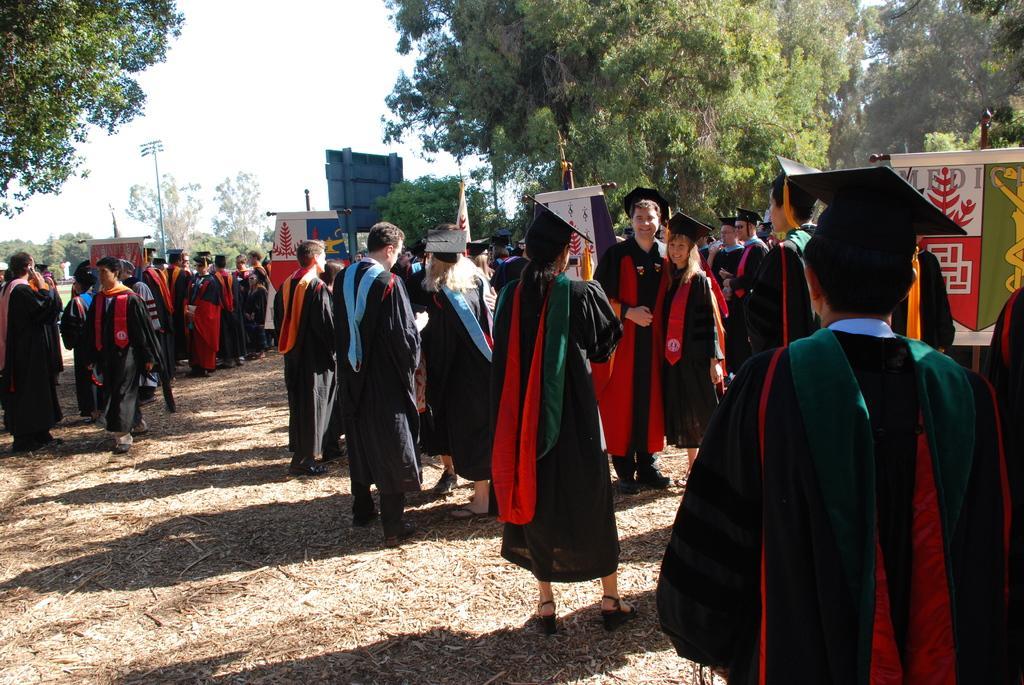How would you summarize this image in a sentence or two? In this picture we can see some girls and boys, standing in the ground wearing convocation black color gowns and taking the photographs. Behind there are some trees. 